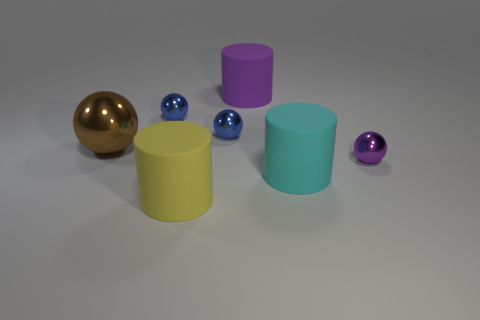What size is the thing that is in front of the cyan cylinder? The object in front of the cyan cylinder is a small purple sphere, significantly smaller in size compared to the nearby cylinders. 